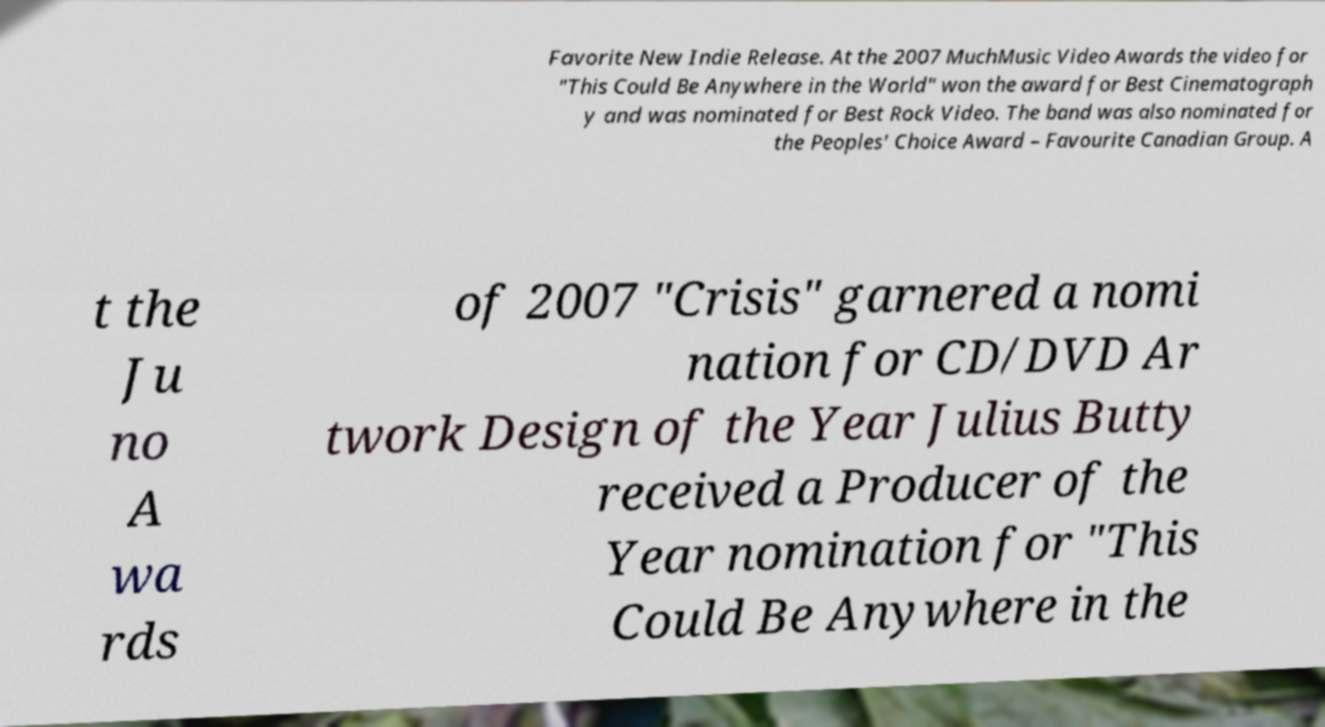Can you read and provide the text displayed in the image?This photo seems to have some interesting text. Can you extract and type it out for me? Favorite New Indie Release. At the 2007 MuchMusic Video Awards the video for "This Could Be Anywhere in the World" won the award for Best Cinematograph y and was nominated for Best Rock Video. The band was also nominated for the Peoples' Choice Award – Favourite Canadian Group. A t the Ju no A wa rds of 2007 "Crisis" garnered a nomi nation for CD/DVD Ar twork Design of the Year Julius Butty received a Producer of the Year nomination for "This Could Be Anywhere in the 